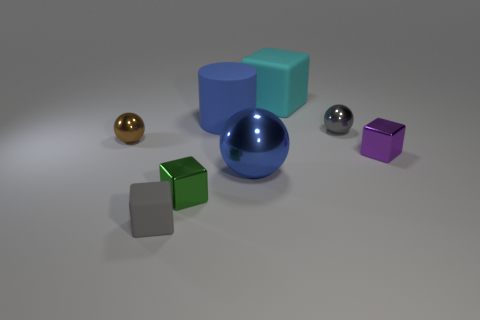Subtract all small balls. How many balls are left? 1 Subtract all purple cubes. How many cubes are left? 3 Add 2 brown balls. How many objects exist? 10 Subtract all cylinders. How many objects are left? 7 Subtract all small red metal cubes. Subtract all small blocks. How many objects are left? 5 Add 7 green metallic cubes. How many green metallic cubes are left? 8 Add 3 small matte cubes. How many small matte cubes exist? 4 Subtract 0 brown blocks. How many objects are left? 8 Subtract all green balls. Subtract all red cylinders. How many balls are left? 3 